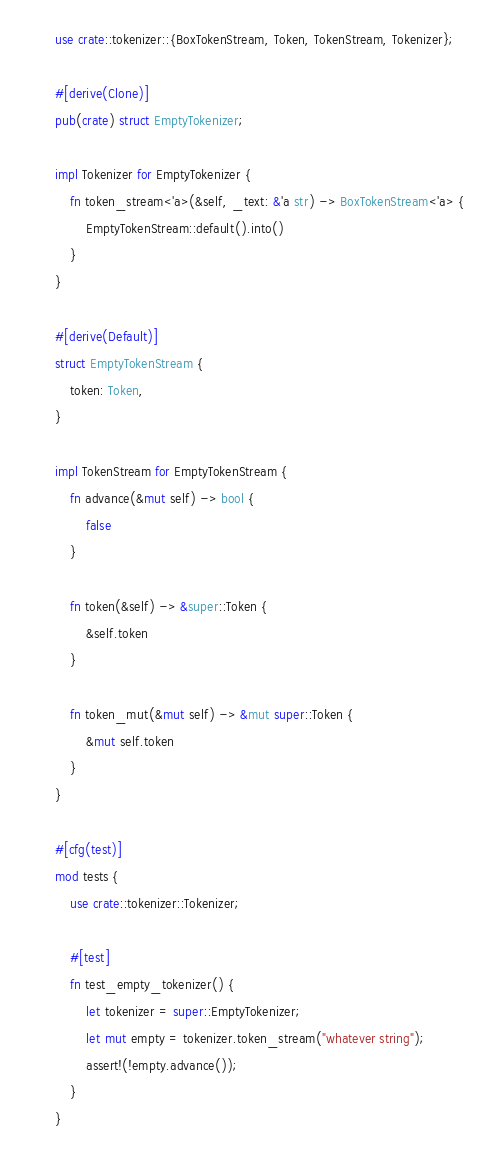Convert code to text. <code><loc_0><loc_0><loc_500><loc_500><_Rust_>use crate::tokenizer::{BoxTokenStream, Token, TokenStream, Tokenizer};

#[derive(Clone)]
pub(crate) struct EmptyTokenizer;

impl Tokenizer for EmptyTokenizer {
    fn token_stream<'a>(&self, _text: &'a str) -> BoxTokenStream<'a> {
        EmptyTokenStream::default().into()
    }
}

#[derive(Default)]
struct EmptyTokenStream {
    token: Token,
}

impl TokenStream for EmptyTokenStream {
    fn advance(&mut self) -> bool {
        false
    }

    fn token(&self) -> &super::Token {
        &self.token
    }

    fn token_mut(&mut self) -> &mut super::Token {
        &mut self.token
    }
}

#[cfg(test)]
mod tests {
    use crate::tokenizer::Tokenizer;

    #[test]
    fn test_empty_tokenizer() {
        let tokenizer = super::EmptyTokenizer;
        let mut empty = tokenizer.token_stream("whatever string");
        assert!(!empty.advance());
    }
}
</code> 